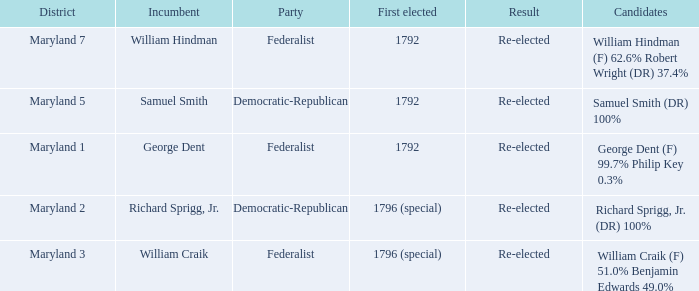What is the party when the incumbent is samuel smith? Democratic-Republican. 